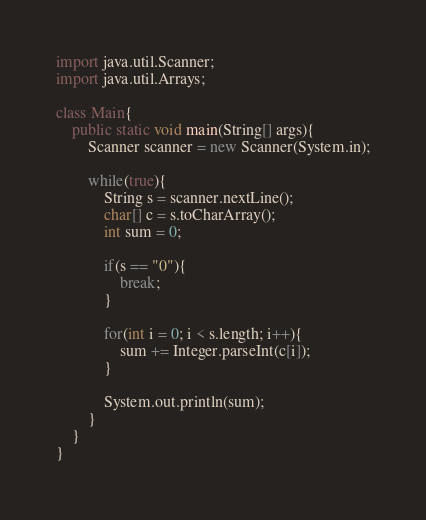Convert code to text. <code><loc_0><loc_0><loc_500><loc_500><_Java_>import java.util.Scanner;
import java.util.Arrays;

class Main{
	public static void main(String[] args){
		Scanner scanner = new Scanner(System.in);
		
		while(true){
			String s = scanner.nextLine();
			char[] c = s.toCharArray();
			int sum = 0;

			if(s == "0"){
				break;
			}

			for(int i = 0; i < s.length; i++){
				sum += Integer.parseInt(c[i]);
			}

			System.out.println(sum);
		}
	}
}</code> 